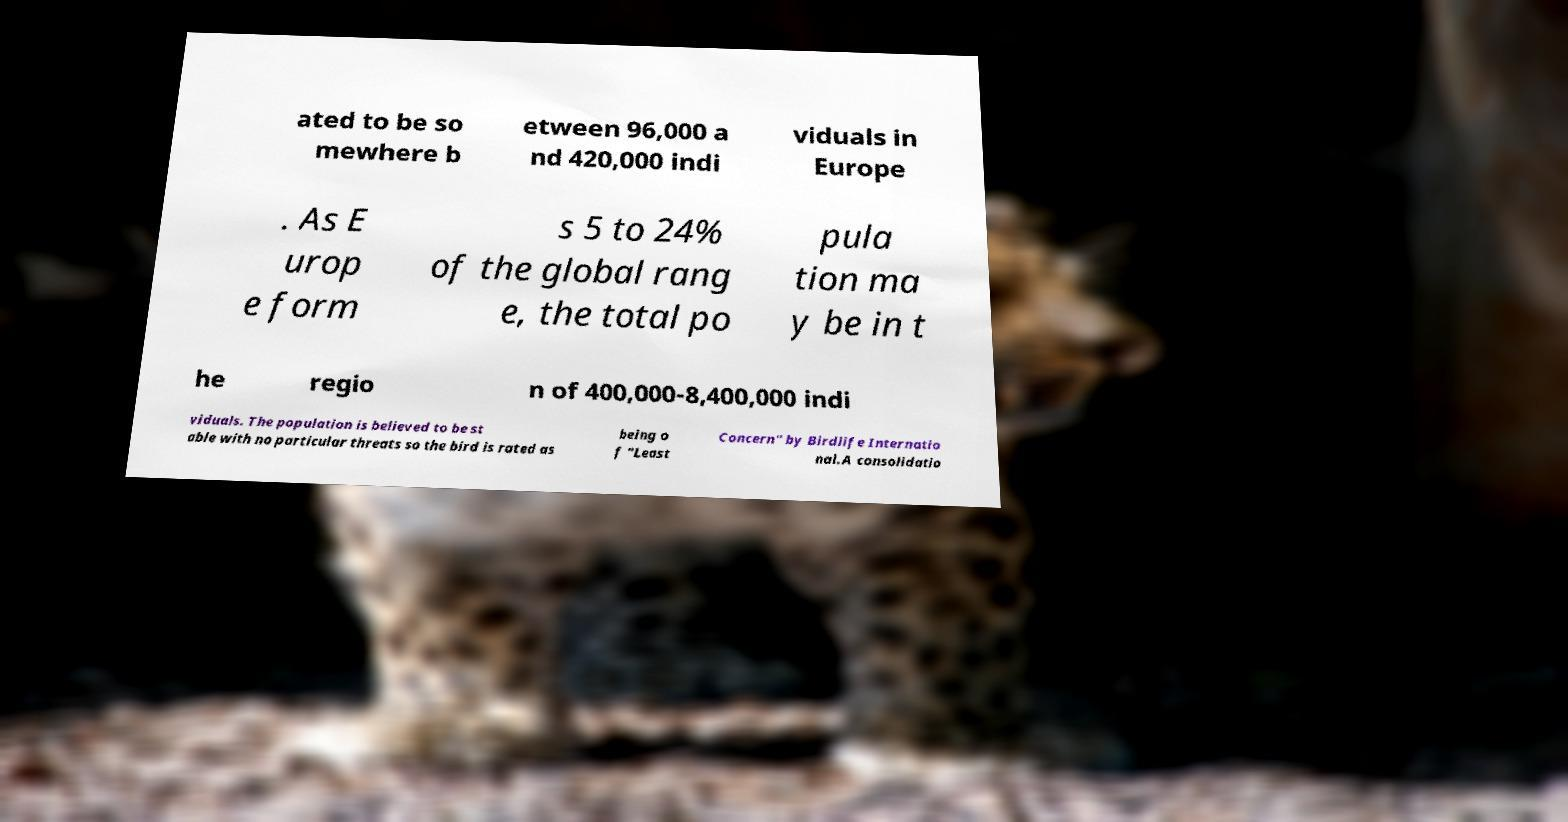I need the written content from this picture converted into text. Can you do that? ated to be so mewhere b etween 96,000 a nd 420,000 indi viduals in Europe . As E urop e form s 5 to 24% of the global rang e, the total po pula tion ma y be in t he regio n of 400,000-8,400,000 indi viduals. The population is believed to be st able with no particular threats so the bird is rated as being o f "Least Concern" by Birdlife Internatio nal.A consolidatio 